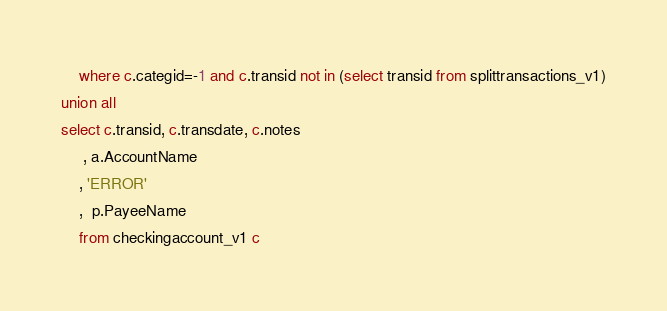<code> <loc_0><loc_0><loc_500><loc_500><_SQL_>    where c.categid=-1 and c.transid not in (select transid from splittransactions_v1)
union all
select c.transid, c.transdate, c.notes
     , a.AccountName
    , 'ERROR'
    ,  p.PayeeName
    from checkingaccount_v1 c</code> 